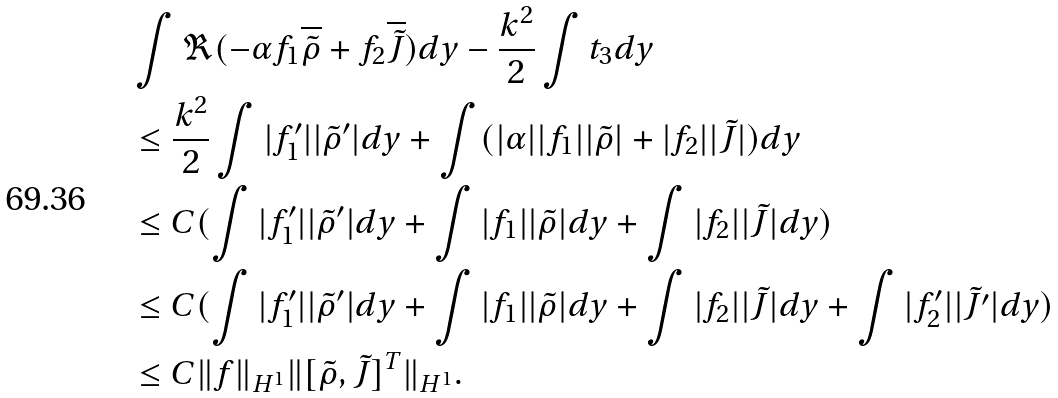Convert formula to latex. <formula><loc_0><loc_0><loc_500><loc_500>& \int \Re ( - \alpha f _ { 1 } \overline { \tilde { \rho } } + f _ { 2 } \overline { \tilde { J } } ) d y - \frac { k ^ { 2 } } { 2 } \int t _ { 3 } d y \\ & \leq \frac { k ^ { 2 } } { 2 } \int | f _ { 1 } ^ { \prime } | | \tilde { \rho } ^ { \prime } | d y + \int ( | \alpha | | f _ { 1 } | | \tilde { \rho } | + | f _ { 2 } | | \tilde { J } | ) d y \\ & \leq C ( \int | f _ { 1 } ^ { \prime } | | \tilde { \rho } ^ { \prime } | d y + \int | f _ { 1 } | | \tilde { \rho } | d y + \int | f _ { 2 } | | \tilde { J } | d y ) \\ & \leq C ( \int | f _ { 1 } ^ { \prime } | | \tilde { \rho } ^ { \prime } | d y + \int | f _ { 1 } | | \tilde { \rho } | d y + \int | f _ { 2 } | | \tilde { J } | d y + \int | f _ { 2 } ^ { \prime } | | \tilde { J ^ { \prime } } | d y ) \\ & \leq C \| f \| _ { H ^ { 1 } } \| [ \tilde { \rho } , \tilde { J } ] ^ { T } \| _ { H ^ { 1 } } .</formula> 